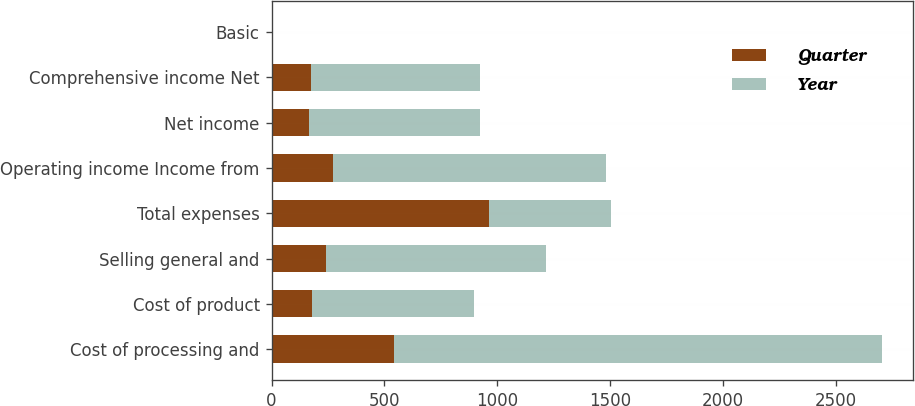<chart> <loc_0><loc_0><loc_500><loc_500><stacked_bar_chart><ecel><fcel>Cost of processing and<fcel>Cost of product<fcel>Selling general and<fcel>Total expenses<fcel>Operating income Income from<fcel>Net income<fcel>Comprehensive income Net<fcel>Basic<nl><fcel>Quarter<fcel>541<fcel>180<fcel>242<fcel>963<fcel>271<fcel>168<fcel>174<fcel>0.66<nl><fcel>Year<fcel>2164<fcel>717<fcel>975<fcel>541<fcel>1210<fcel>754<fcel>751<fcel>3.04<nl></chart> 